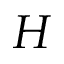Convert formula to latex. <formula><loc_0><loc_0><loc_500><loc_500>H</formula> 